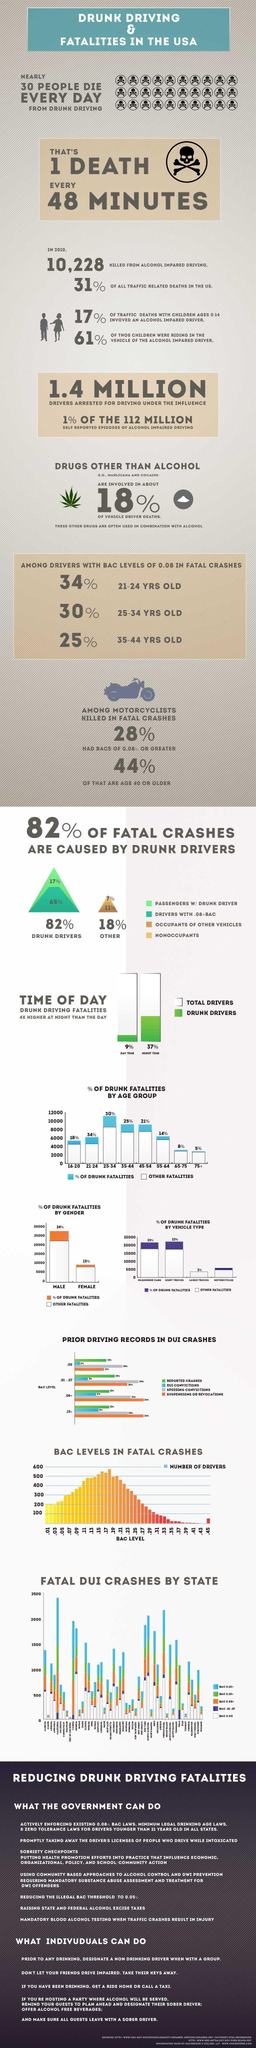What is the percentage of drunk driving fatalities during the night time in U.S.?
Answer the question with a short phrase. 37% What is the percent of drunk fatalities caused by females in the U.S.? 15% What percent of fatal crashes are caused by drunk drivers accompanying the passengers? 17% Which type of vehicle reported higher percent of drunk fatalities in U.S.? PASSENGER CARS What is the percentage of drunk driving fatalities during the day time in U.S.? 9% How many people were killed from alcohol impared driving in the U.S. in 2010? 10,228 What is the percentage of all traffic related deaths in the U.S. in 2010? 31% In which gender, the percent of drunk fatalities is the highest in the U.S? Male What is the percentage of drunk fatalities in the age group of 25-34 in U.S.? 30% 